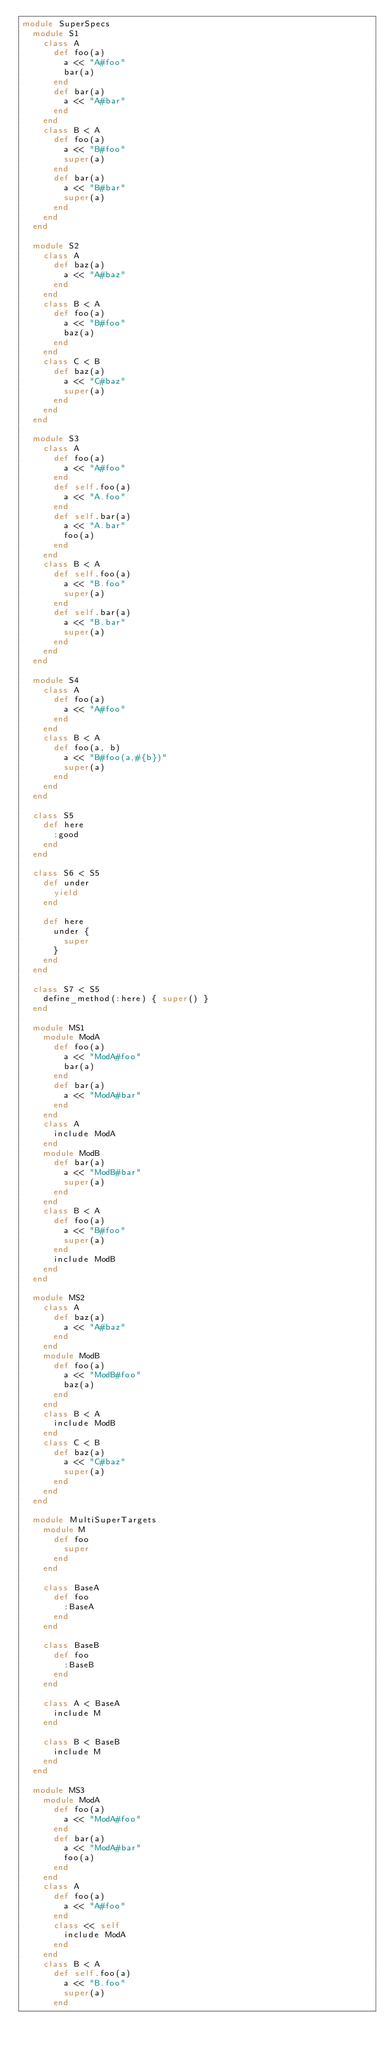Convert code to text. <code><loc_0><loc_0><loc_500><loc_500><_Ruby_>module SuperSpecs
  module S1
    class A
      def foo(a)
        a << "A#foo"
        bar(a)
      end
      def bar(a)
        a << "A#bar"
      end
    end
    class B < A
      def foo(a)
        a << "B#foo"
        super(a)
      end
      def bar(a)
        a << "B#bar"
        super(a)
      end
    end
  end

  module S2
    class A
      def baz(a)
        a << "A#baz"
      end
    end
    class B < A
      def foo(a)
        a << "B#foo"
        baz(a)
      end
    end
    class C < B
      def baz(a)
        a << "C#baz"
        super(a)
      end
    end
  end

  module S3
    class A
      def foo(a)
        a << "A#foo"
      end
      def self.foo(a)
        a << "A.foo"
      end
      def self.bar(a)
        a << "A.bar"
        foo(a)
      end
    end
    class B < A
      def self.foo(a)
        a << "B.foo"
        super(a)
      end
      def self.bar(a)
        a << "B.bar"
        super(a)
      end
    end
  end

  module S4
    class A
      def foo(a)
        a << "A#foo"
      end
    end
    class B < A
      def foo(a, b)
        a << "B#foo(a,#{b})"
        super(a)
      end
    end
  end

  class S5
    def here
      :good
    end
  end

  class S6 < S5
    def under
      yield
    end

    def here
      under {
        super
      }
    end
  end

  class S7 < S5
    define_method(:here) { super() }
  end

  module MS1
    module ModA
      def foo(a)
        a << "ModA#foo"
        bar(a)
      end
      def bar(a)
        a << "ModA#bar"
      end
    end
    class A
      include ModA
    end
    module ModB
      def bar(a)
        a << "ModB#bar"
        super(a)
      end
    end
    class B < A
      def foo(a)
        a << "B#foo"
        super(a)
      end
      include ModB
    end
  end

  module MS2
    class A
      def baz(a)
        a << "A#baz"
      end
    end
    module ModB
      def foo(a)
        a << "ModB#foo"
        baz(a)
      end
    end
    class B < A
      include ModB
    end
    class C < B
      def baz(a)
        a << "C#baz"
        super(a)
      end
    end
  end

  module MultiSuperTargets
    module M
      def foo
        super
      end
    end

    class BaseA
      def foo
        :BaseA
      end
    end

    class BaseB
      def foo
        :BaseB
      end
    end

    class A < BaseA
      include M
    end

    class B < BaseB
      include M
    end
  end

  module MS3
    module ModA
      def foo(a)
        a << "ModA#foo"
      end
      def bar(a)
        a << "ModA#bar"
        foo(a)
      end
    end
    class A
      def foo(a)
        a << "A#foo"
      end
      class << self
        include ModA
      end
    end
    class B < A
      def self.foo(a)
        a << "B.foo"
        super(a)
      end</code> 